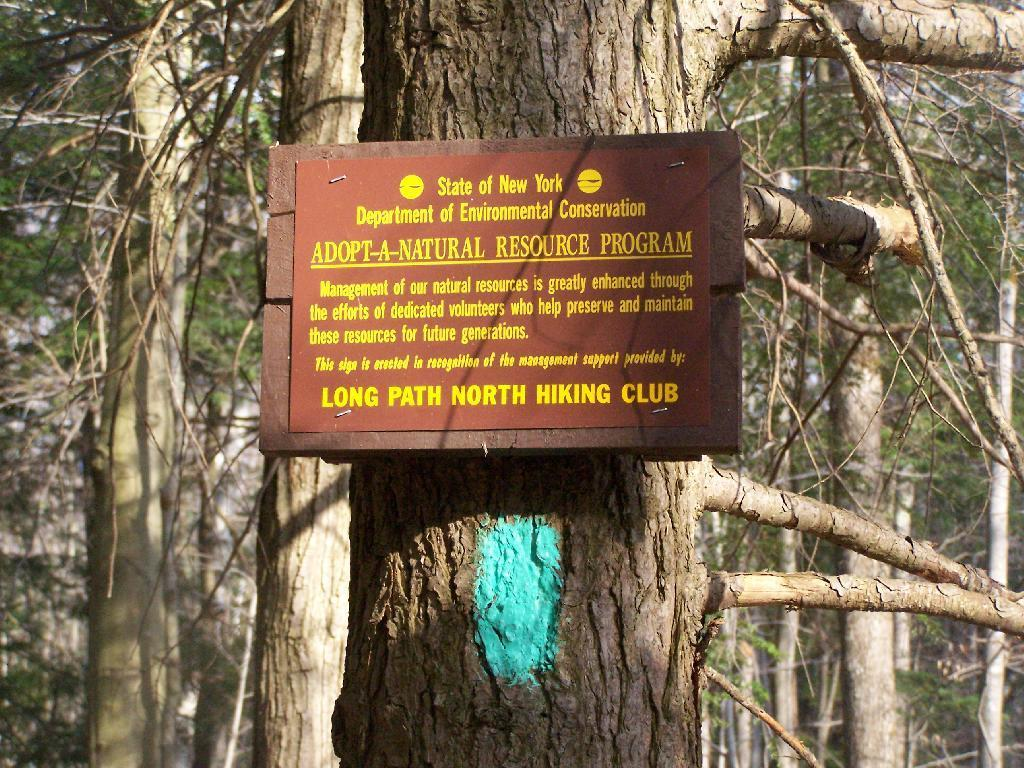What is on the wooden board in the image? There is a poster on a wooden board in the image. What can be seen on the ground in the image? There is a tree trunk in the image. What type of natural environment is visible in the background of the image? There are multiple trees visible in the background of the image. How far away is the wilderness from the poster in the image? There is no wilderness present in the image, so it is not possible to determine the distance between it and the poster. What type of spacecraft can be seen in the image? There are no spacecraft present in the image. 